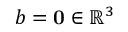<formula> <loc_0><loc_0><loc_500><loc_500>b = 0 \in \mathbb { R } ^ { 3 }</formula> 